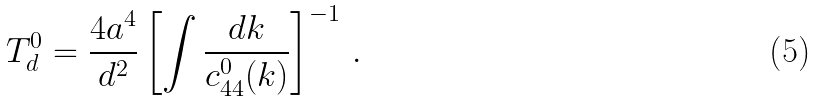<formula> <loc_0><loc_0><loc_500><loc_500>T _ { d } ^ { 0 } = \frac { 4 a ^ { 4 } } { d ^ { 2 } } \left [ \int \frac { d k } { c _ { 4 4 } ^ { 0 } ( k ) } \right ] ^ { - 1 } \, .</formula> 